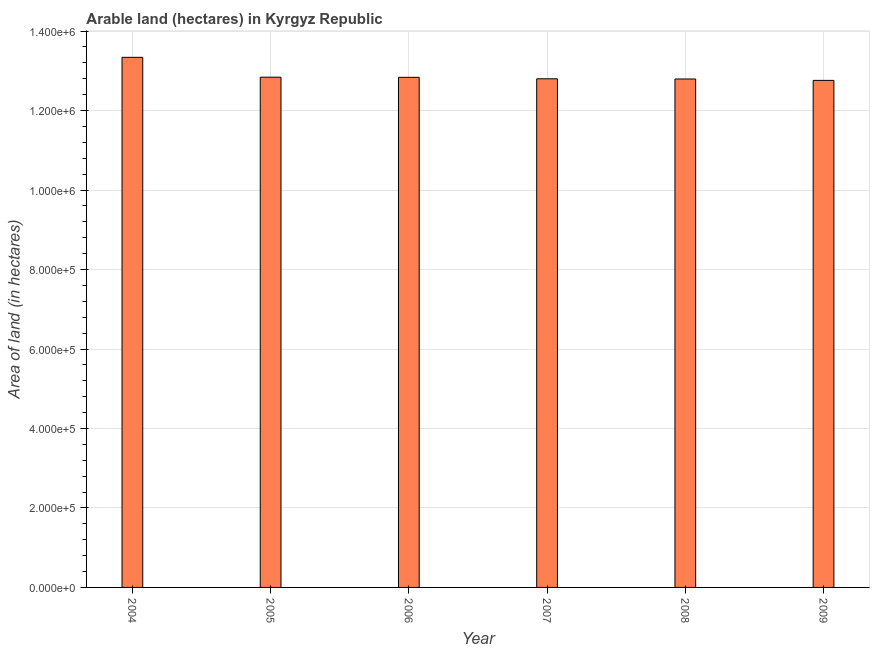Does the graph contain any zero values?
Ensure brevity in your answer.  No. What is the title of the graph?
Keep it short and to the point. Arable land (hectares) in Kyrgyz Republic. What is the label or title of the Y-axis?
Your answer should be very brief. Area of land (in hectares). What is the area of land in 2004?
Your response must be concise. 1.33e+06. Across all years, what is the maximum area of land?
Ensure brevity in your answer.  1.33e+06. Across all years, what is the minimum area of land?
Ensure brevity in your answer.  1.28e+06. In which year was the area of land maximum?
Your response must be concise. 2004. In which year was the area of land minimum?
Your answer should be very brief. 2009. What is the sum of the area of land?
Offer a terse response. 7.74e+06. What is the difference between the area of land in 2005 and 2009?
Provide a short and direct response. 8000. What is the average area of land per year?
Your response must be concise. 1.29e+06. What is the median area of land?
Ensure brevity in your answer.  1.28e+06. Do a majority of the years between 2007 and 2005 (inclusive) have area of land greater than 840000 hectares?
Offer a very short reply. Yes. What is the difference between the highest and the lowest area of land?
Provide a short and direct response. 5.80e+04. Are all the bars in the graph horizontal?
Your answer should be very brief. No. Are the values on the major ticks of Y-axis written in scientific E-notation?
Provide a succinct answer. Yes. What is the Area of land (in hectares) of 2004?
Keep it short and to the point. 1.33e+06. What is the Area of land (in hectares) of 2005?
Offer a very short reply. 1.28e+06. What is the Area of land (in hectares) in 2006?
Your answer should be compact. 1.28e+06. What is the Area of land (in hectares) of 2007?
Offer a terse response. 1.28e+06. What is the Area of land (in hectares) of 2008?
Your answer should be very brief. 1.28e+06. What is the Area of land (in hectares) of 2009?
Make the answer very short. 1.28e+06. What is the difference between the Area of land (in hectares) in 2004 and 2005?
Your response must be concise. 5.00e+04. What is the difference between the Area of land (in hectares) in 2004 and 2006?
Give a very brief answer. 5.03e+04. What is the difference between the Area of land (in hectares) in 2004 and 2007?
Provide a short and direct response. 5.40e+04. What is the difference between the Area of land (in hectares) in 2004 and 2008?
Ensure brevity in your answer.  5.45e+04. What is the difference between the Area of land (in hectares) in 2004 and 2009?
Make the answer very short. 5.80e+04. What is the difference between the Area of land (in hectares) in 2005 and 2006?
Ensure brevity in your answer.  300. What is the difference between the Area of land (in hectares) in 2005 and 2007?
Your answer should be compact. 4000. What is the difference between the Area of land (in hectares) in 2005 and 2008?
Ensure brevity in your answer.  4500. What is the difference between the Area of land (in hectares) in 2005 and 2009?
Give a very brief answer. 8000. What is the difference between the Area of land (in hectares) in 2006 and 2007?
Make the answer very short. 3700. What is the difference between the Area of land (in hectares) in 2006 and 2008?
Offer a very short reply. 4200. What is the difference between the Area of land (in hectares) in 2006 and 2009?
Make the answer very short. 7700. What is the difference between the Area of land (in hectares) in 2007 and 2009?
Ensure brevity in your answer.  4000. What is the difference between the Area of land (in hectares) in 2008 and 2009?
Make the answer very short. 3500. What is the ratio of the Area of land (in hectares) in 2004 to that in 2005?
Your answer should be very brief. 1.04. What is the ratio of the Area of land (in hectares) in 2004 to that in 2006?
Make the answer very short. 1.04. What is the ratio of the Area of land (in hectares) in 2004 to that in 2007?
Keep it short and to the point. 1.04. What is the ratio of the Area of land (in hectares) in 2004 to that in 2008?
Make the answer very short. 1.04. What is the ratio of the Area of land (in hectares) in 2004 to that in 2009?
Offer a terse response. 1.04. What is the ratio of the Area of land (in hectares) in 2005 to that in 2006?
Offer a very short reply. 1. What is the ratio of the Area of land (in hectares) in 2005 to that in 2007?
Offer a very short reply. 1. What is the ratio of the Area of land (in hectares) in 2005 to that in 2008?
Your answer should be very brief. 1. What is the ratio of the Area of land (in hectares) in 2005 to that in 2009?
Your answer should be very brief. 1.01. What is the ratio of the Area of land (in hectares) in 2006 to that in 2007?
Provide a succinct answer. 1. What is the ratio of the Area of land (in hectares) in 2006 to that in 2008?
Your answer should be compact. 1. What is the ratio of the Area of land (in hectares) in 2008 to that in 2009?
Ensure brevity in your answer.  1. 